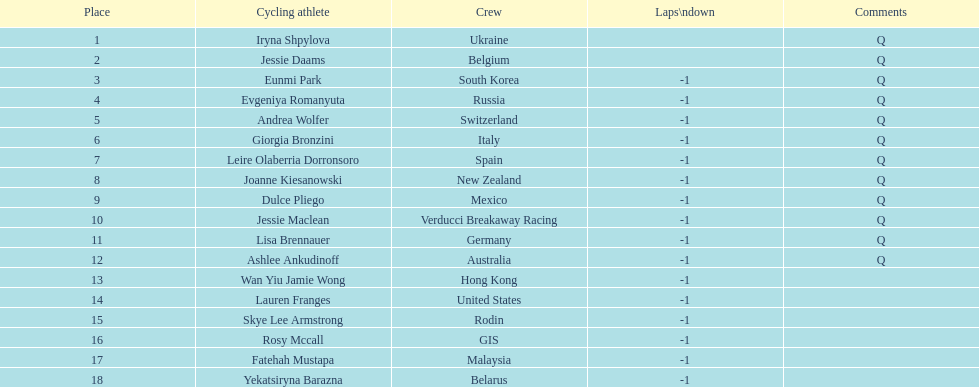Who was the competitor that finished above jessie maclean? Dulce Pliego. 